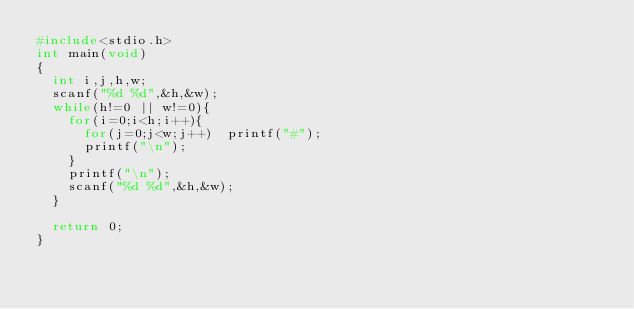Convert code to text. <code><loc_0><loc_0><loc_500><loc_500><_C_>#include<stdio.h>
int main(void)
{
  int i,j,h,w;
  scanf("%d %d",&h,&w);
  while(h!=0 || w!=0){
    for(i=0;i<h;i++){
      for(j=0;j<w;j++)  printf("#");
      printf("\n");
    }
    printf("\n");
    scanf("%d %d",&h,&w);
  }

  return 0;
}</code> 